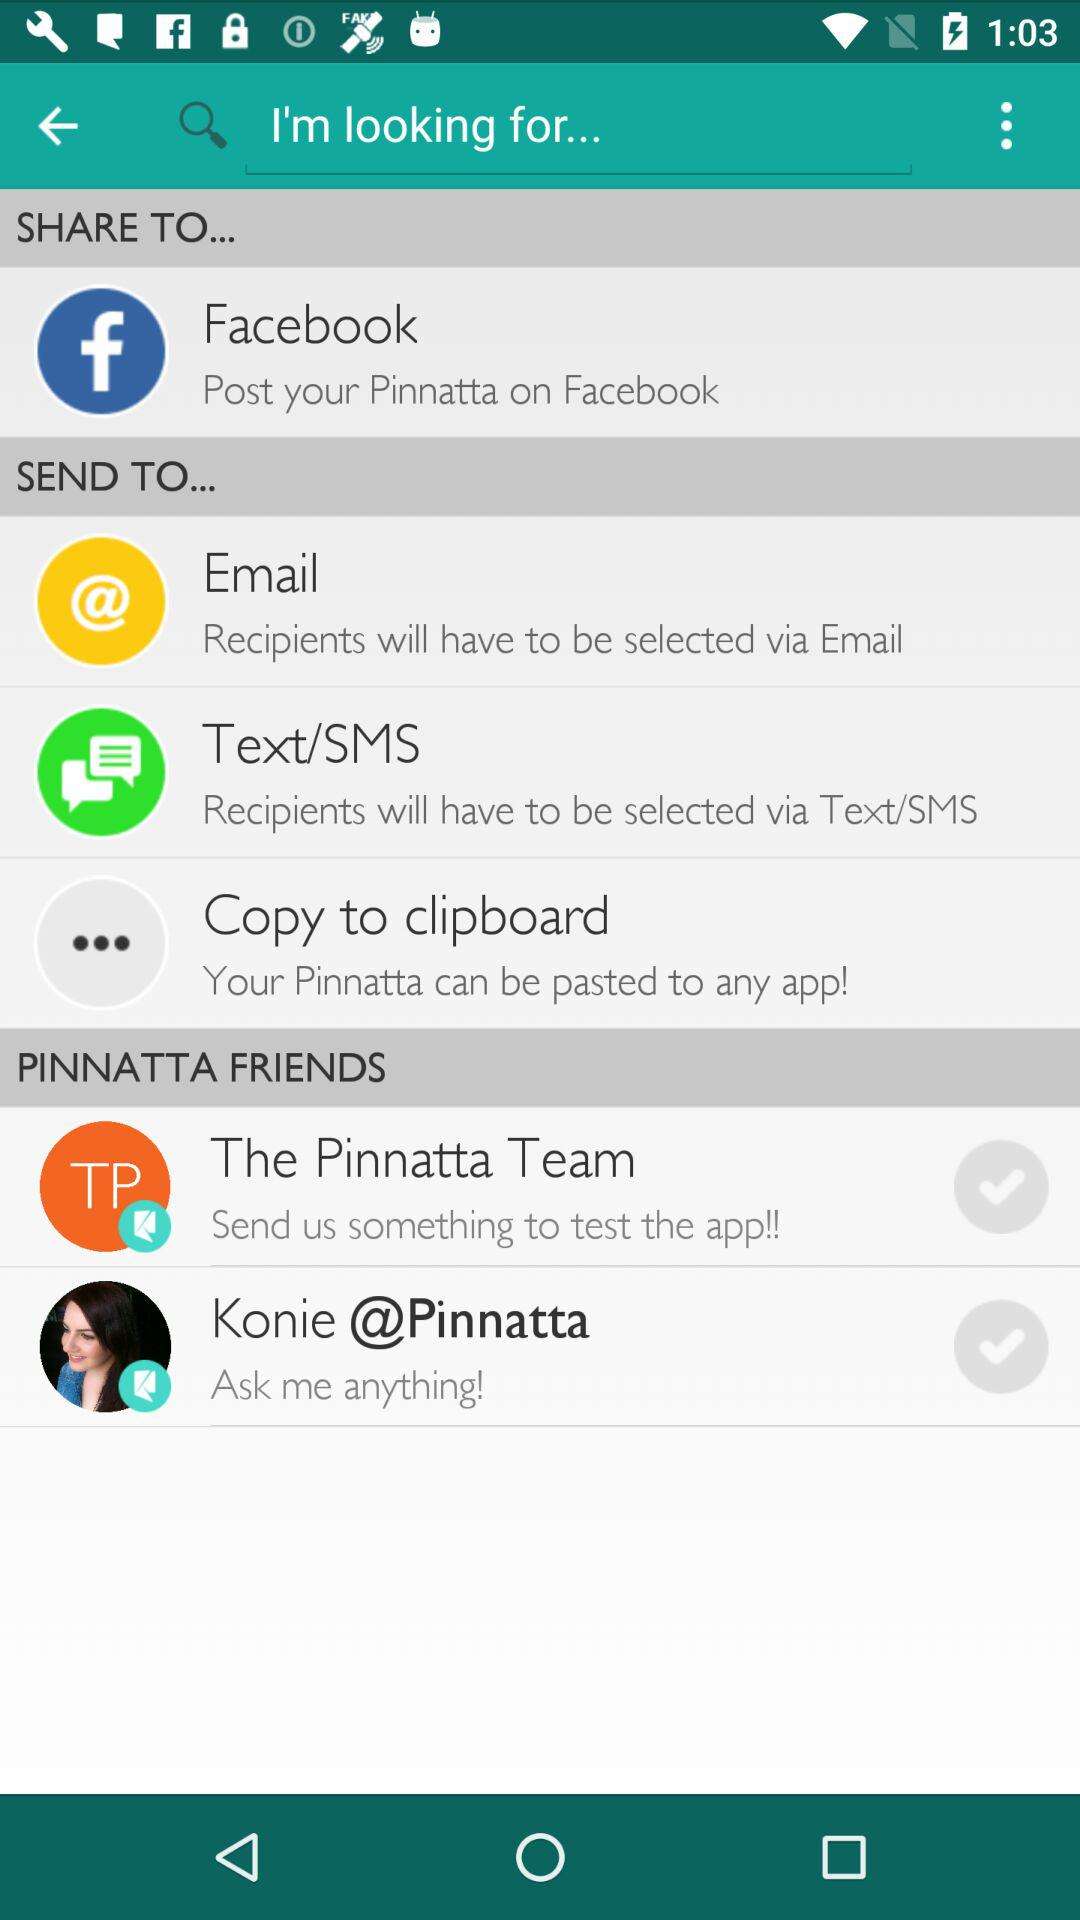Where can you share? You can share it on "Facebook". 